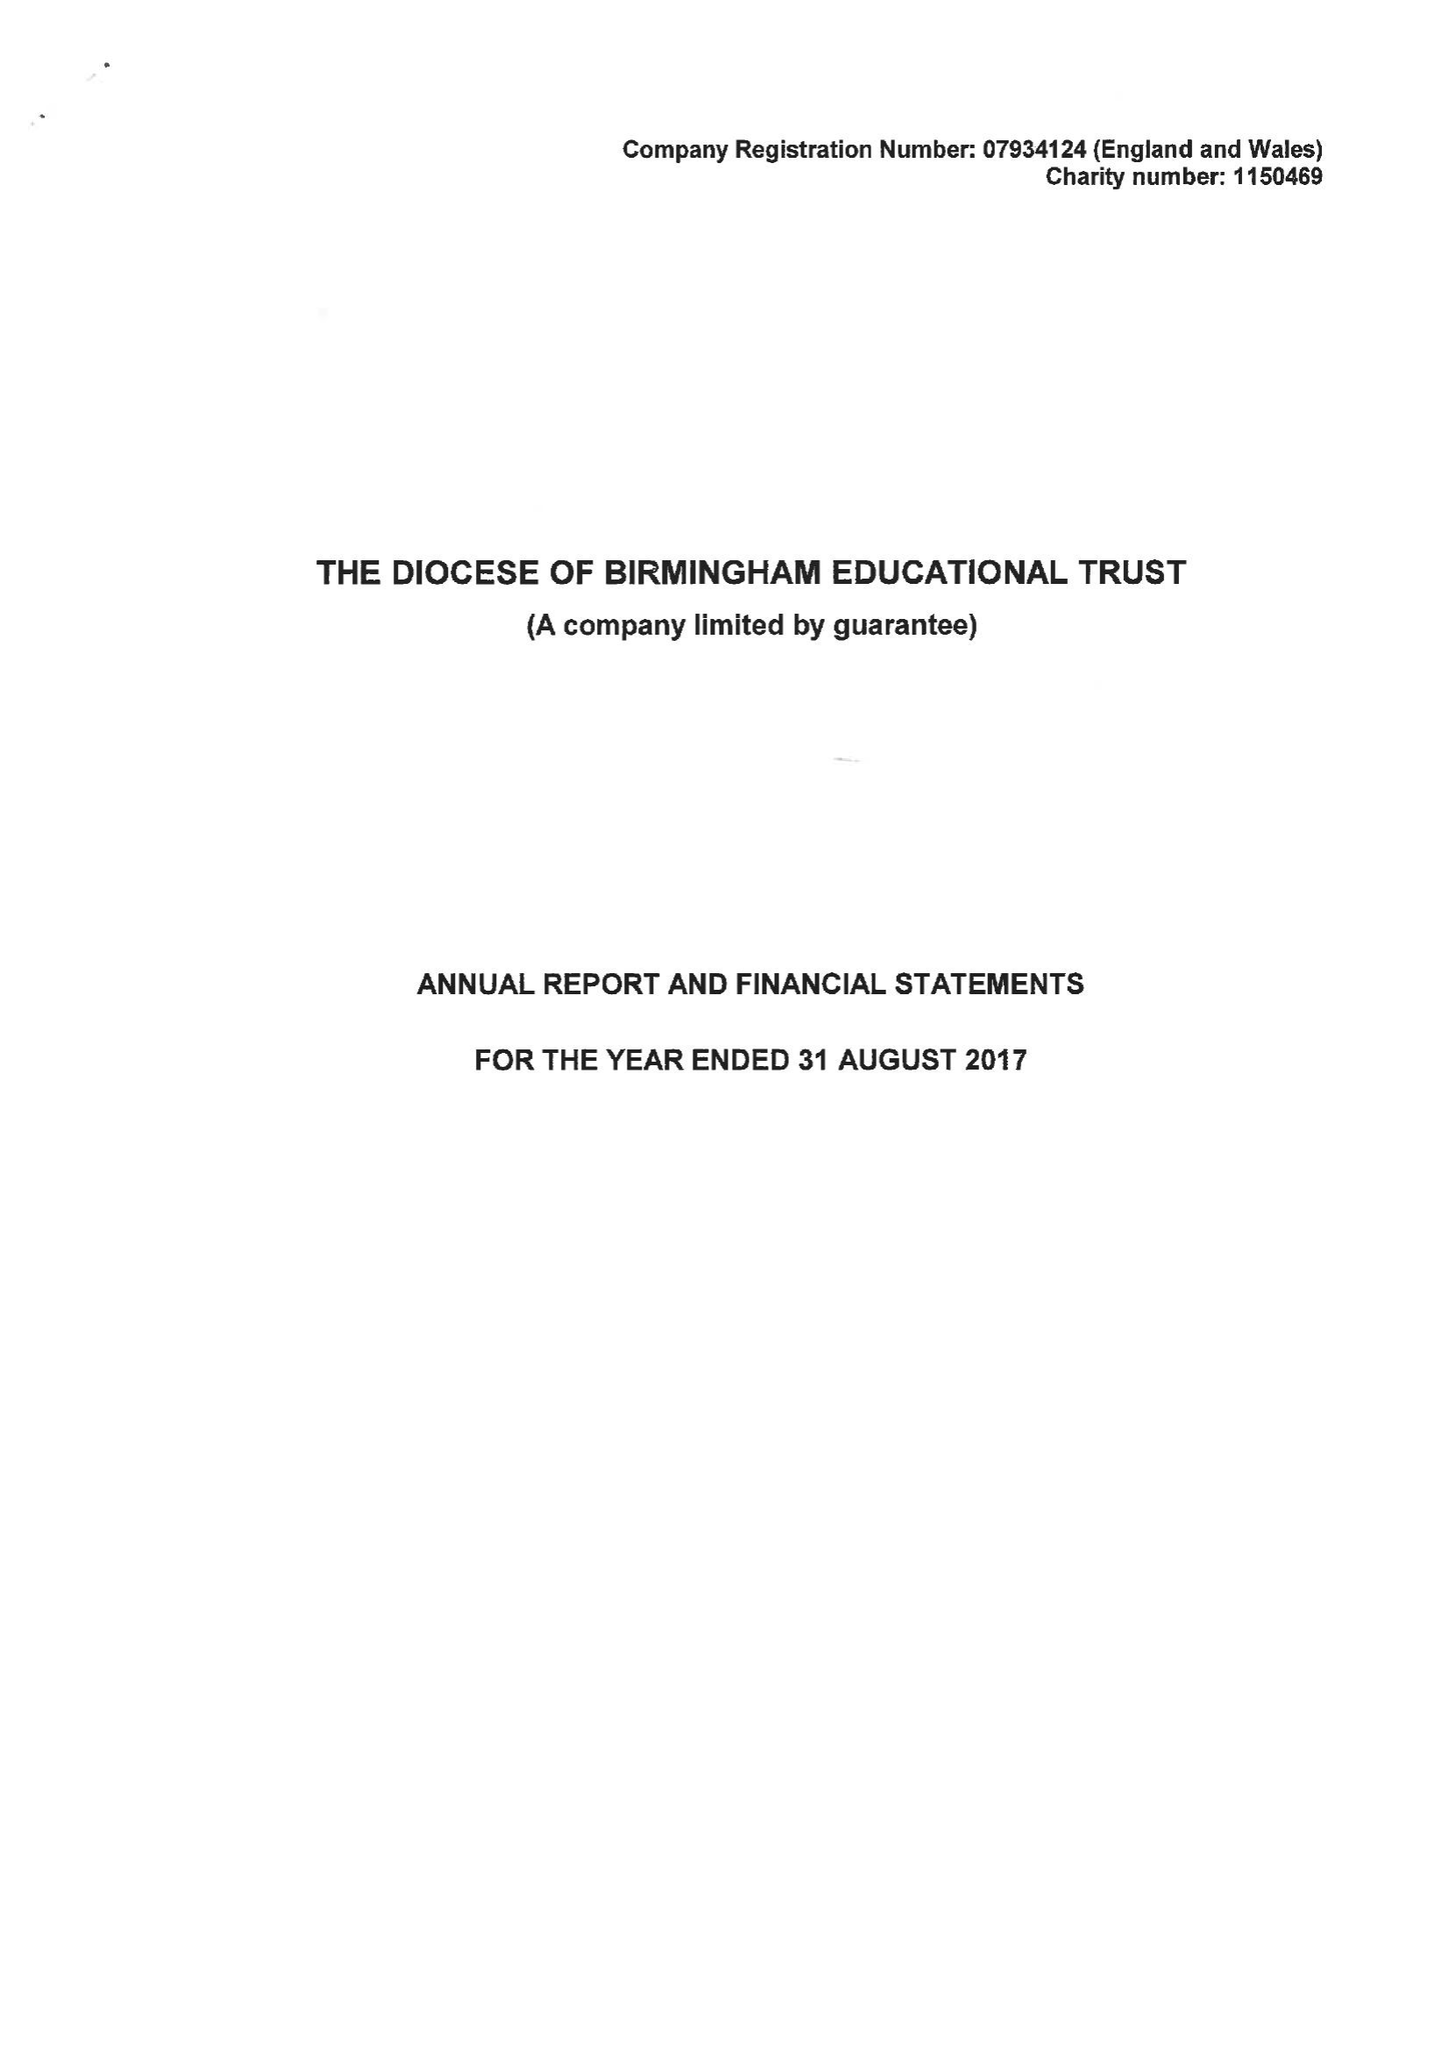What is the value for the charity_name?
Answer the question using a single word or phrase. The Diocese Of Birmingham Educational Trust 